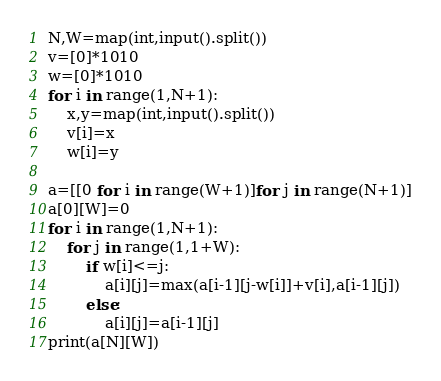<code> <loc_0><loc_0><loc_500><loc_500><_Python_>N,W=map(int,input().split())
v=[0]*1010
w=[0]*1010
for i in range(1,N+1):
    x,y=map(int,input().split())
    v[i]=x
    w[i]=y
    
a=[[0 for i in range(W+1)]for j in range(N+1)]
a[0][W]=0
for i in range(1,N+1):
    for j in range(1,1+W):
        if w[i]<=j:
            a[i][j]=max(a[i-1][j-w[i]]+v[i],a[i-1][j])
        else:
            a[i][j]=a[i-1][j]
print(a[N][W])
</code> 